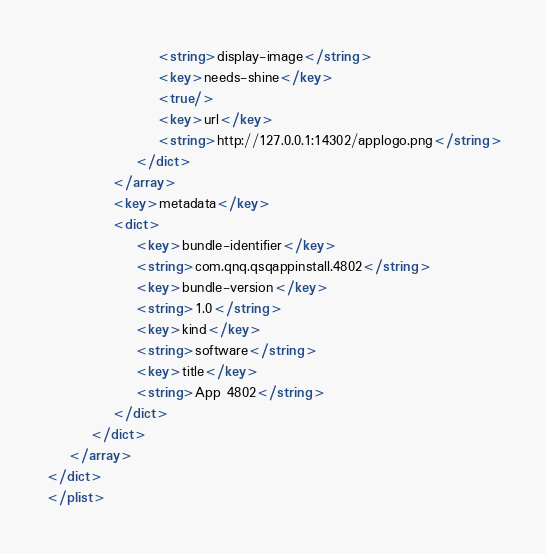Convert code to text. <code><loc_0><loc_0><loc_500><loc_500><_XML_>					<string>display-image</string>
					<key>needs-shine</key>
					<true/>
					<key>url</key>
					<string>http://127.0.0.1:14302/applogo.png</string>
				</dict>
			</array>
			<key>metadata</key>
			<dict>
				<key>bundle-identifier</key>
				<string>com.qnq.qsqappinstall.4802</string>
				<key>bundle-version</key>
				<string>1.0</string>
				<key>kind</key>
				<string>software</string>
				<key>title</key>
				<string>App 4802</string>
			</dict>
		</dict>
	</array>
</dict>
</plist>
</code> 